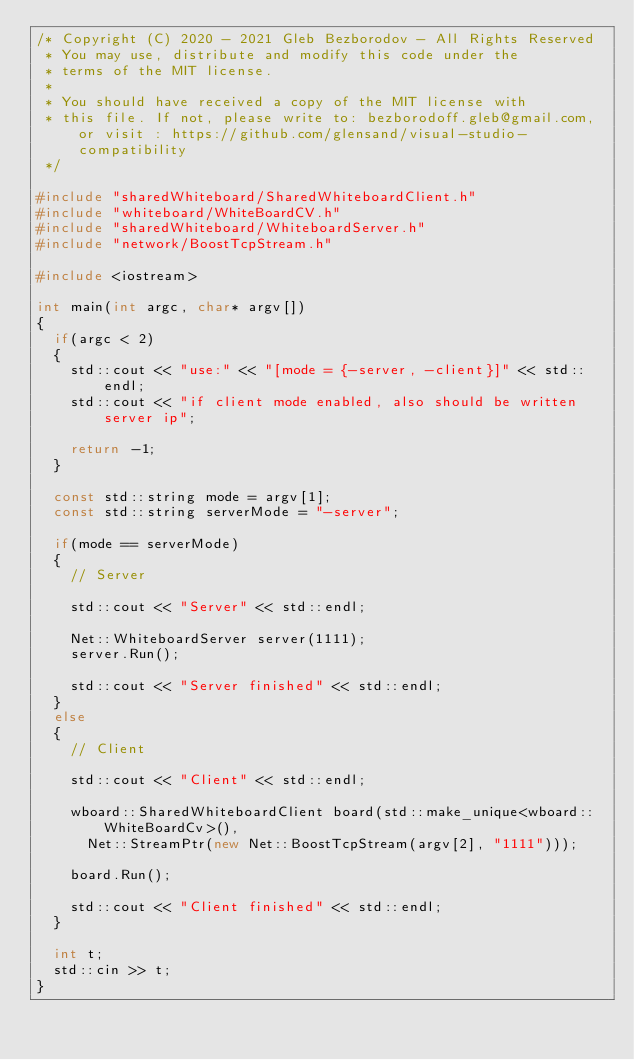<code> <loc_0><loc_0><loc_500><loc_500><_C++_>/* Copyright (C) 2020 - 2021 Gleb Bezborodov - All Rights Reserved
 * You may use, distribute and modify this code under the
 * terms of the MIT license.
 *
 * You should have received a copy of the MIT license with
 * this file. If not, please write to: bezborodoff.gleb@gmail.com, or visit : https://github.com/glensand/visual-studio-compatibility
 */

#include "sharedWhiteboard/SharedWhiteboardClient.h"
#include "whiteboard/WhiteBoardCV.h"
#include "sharedWhiteboard/WhiteboardServer.h"
#include "network/BoostTcpStream.h"

#include <iostream>

int main(int argc, char* argv[])
{	
	if(argc < 2)
	{
		std::cout << "use:" << "[mode = {-server, -client}]" << std::endl;
		std::cout << "if client mode enabled, also should be written server ip";

		return -1;
	}

	const std::string mode = argv[1];
	const std::string serverMode = "-server";
	
	if(mode == serverMode)
	{	
		// Server

		std::cout << "Server" << std::endl;
		
		Net::WhiteboardServer server(1111);
		server.Run();

		std::cout << "Server finished" << std::endl;
	}
	else
	{
		// Client

		std::cout << "Client" << std::endl;
		
		wboard::SharedWhiteboardClient board(std::make_unique<wboard::WhiteBoardCv>(), 
			Net::StreamPtr(new Net::BoostTcpStream(argv[2], "1111")));
		
		board.Run();

		std::cout << "Client finished" << std::endl;
	}

	int t;
	std::cin >> t;
}
</code> 